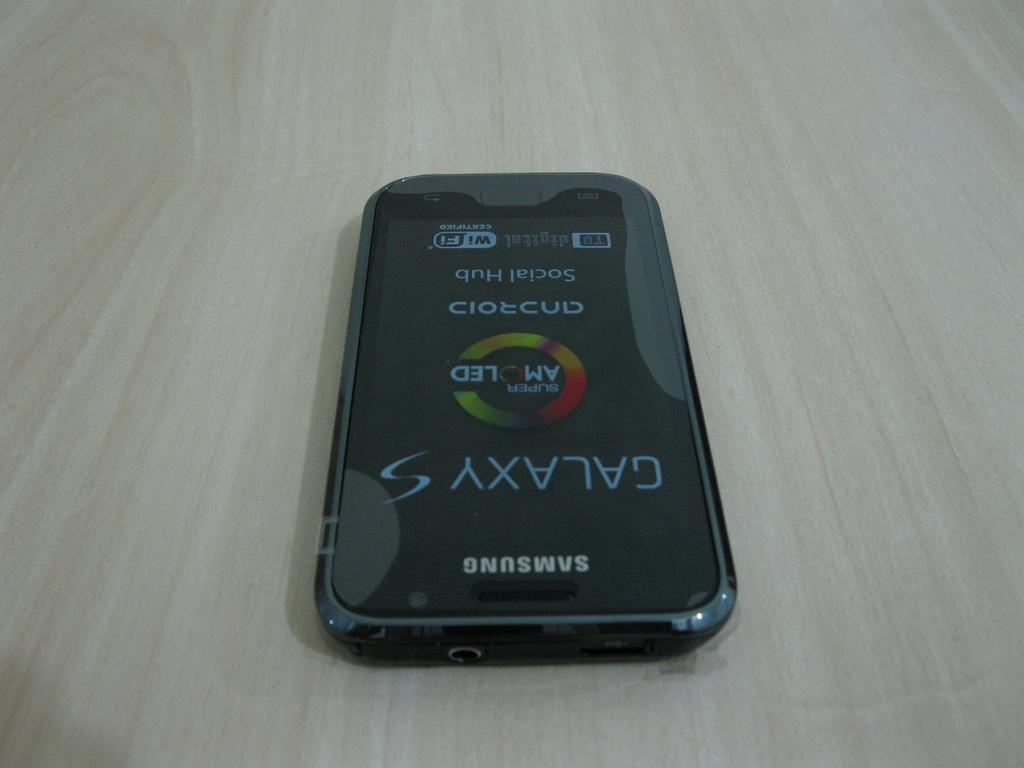<image>
Give a short and clear explanation of the subsequent image. A phone has the word Galaxy under the word Samsung. 